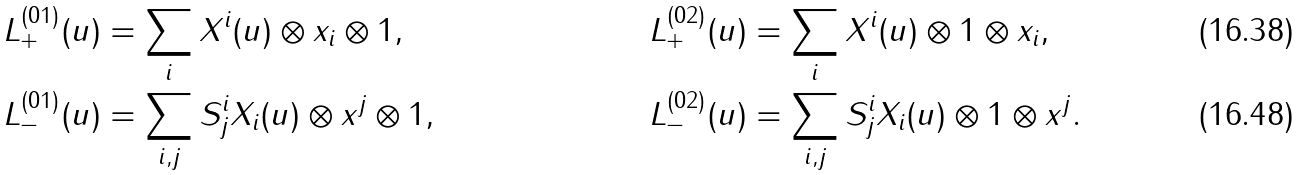Convert formula to latex. <formula><loc_0><loc_0><loc_500><loc_500>L ^ { ( 0 1 ) } _ { + } ( u ) & = \sum _ { i } X ^ { i } ( u ) \otimes x _ { i } \otimes 1 , & L ^ { ( 0 2 ) } _ { + } ( u ) & = \sum _ { i } X ^ { i } ( u ) \otimes 1 \otimes x _ { i } , \\ L ^ { ( 0 1 ) } _ { - } ( u ) & = \sum _ { i , j } S ^ { i } _ { j } X _ { i } ( u ) \otimes x ^ { j } \otimes 1 , & L ^ { ( 0 2 ) } _ { - } ( u ) & = \sum _ { i , j } S ^ { i } _ { j } X _ { i } ( u ) \otimes 1 \otimes x ^ { j } .</formula> 